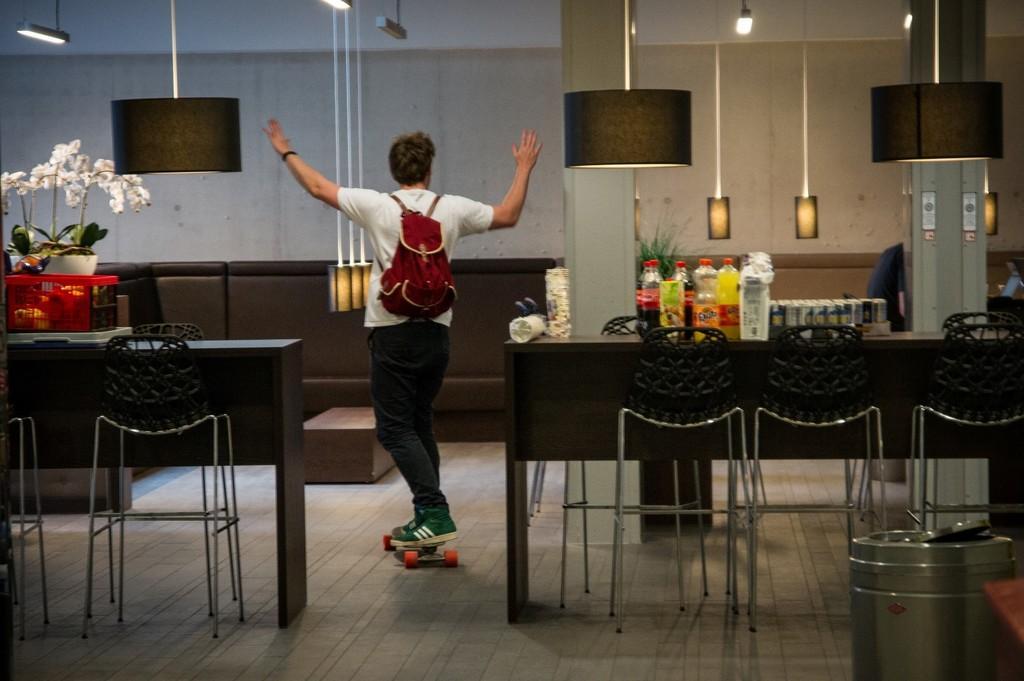Please provide a concise description of this image. In this picture there is a man skating on a skateboard holding a bag on his shoulders. There are some tables of with some bottles are placed and there are some chairs. There is a flower pot on the left side in the background. There is a wall and lamp here. 